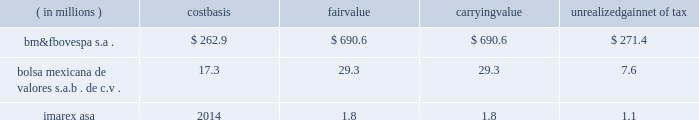Subject to fluctuation and , consequently , the amount realized in the subsequent sale of an investment may differ significantly from its current reported value .
Fluctuations in the market price of a security may result from perceived changes in the underlying economic characteristics of the issuer , the relative price of alternative investments and general market conditions .
The table below summarizes equity investments that are subject to equity price fluctuations at december 31 , 2012 .
Equity investments are included in other assets in our consolidated balance sheets .
( in millions ) carrying unrealized net of tax .
We do not currently hedge against equity price risk .
Equity investments are assessed for other-than- temporary impairment on a quarterly basis. .
What is the unrealized gain pre-tex for bolsa mexicana de valores? 
Computations: (29.3 - 17.3)
Answer: 12.0. 